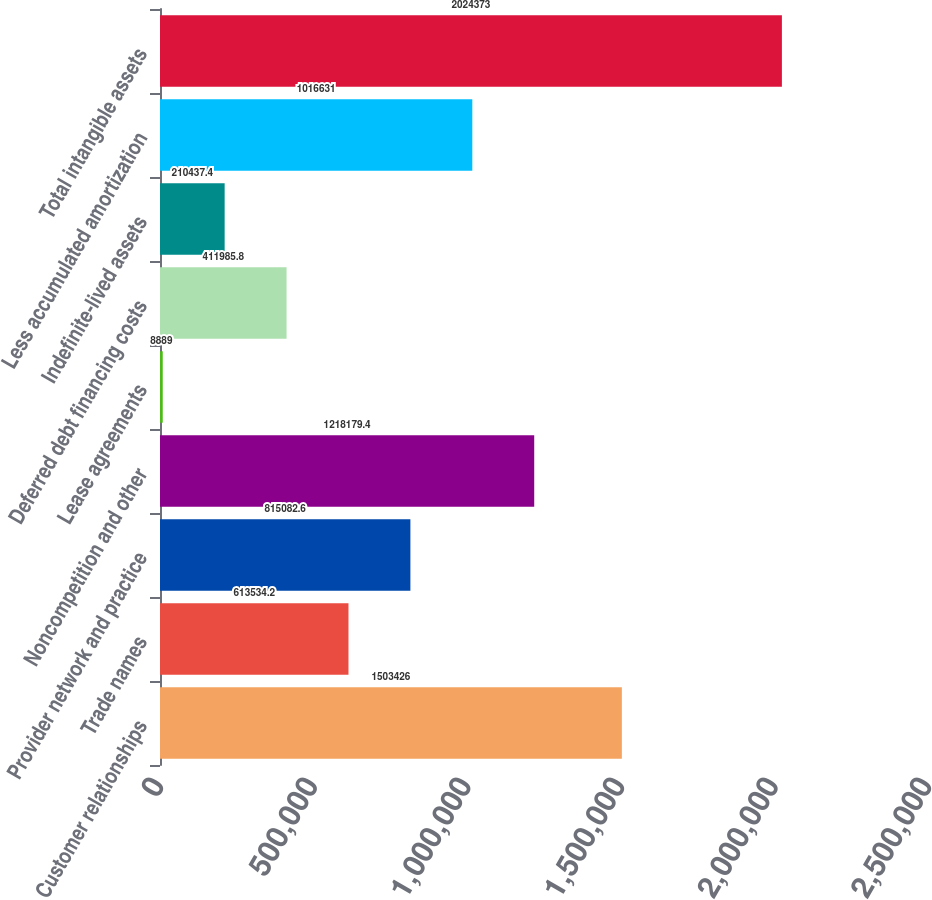Convert chart. <chart><loc_0><loc_0><loc_500><loc_500><bar_chart><fcel>Customer relationships<fcel>Trade names<fcel>Provider network and practice<fcel>Noncompetition and other<fcel>Lease agreements<fcel>Deferred debt financing costs<fcel>Indefinite-lived assets<fcel>Less accumulated amortization<fcel>Total intangible assets<nl><fcel>1.50343e+06<fcel>613534<fcel>815083<fcel>1.21818e+06<fcel>8889<fcel>411986<fcel>210437<fcel>1.01663e+06<fcel>2.02437e+06<nl></chart> 